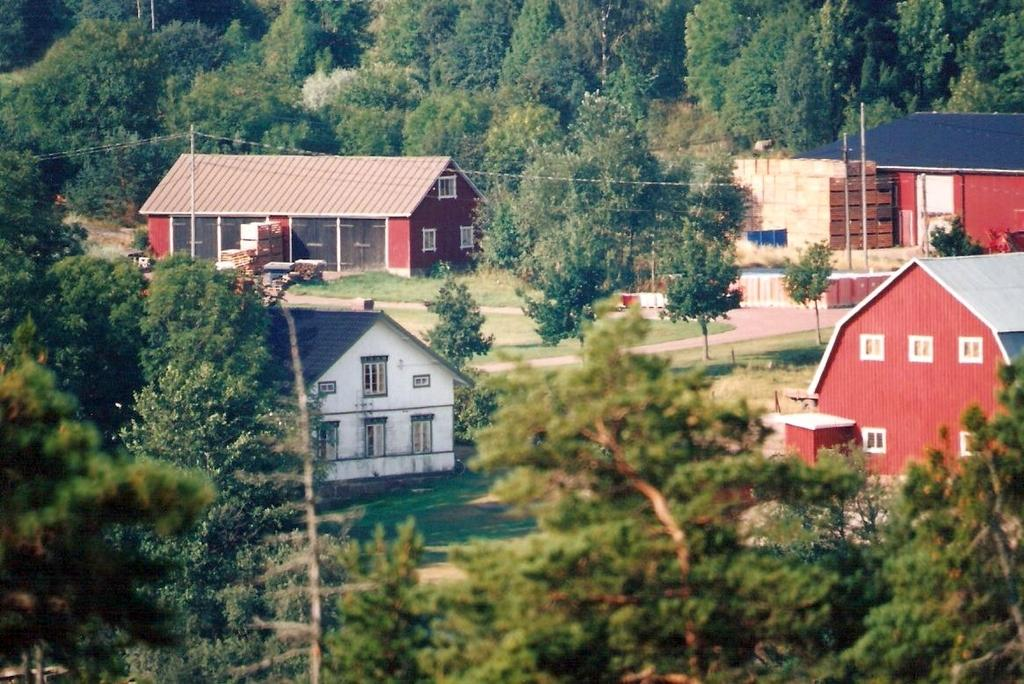What type of structures can be seen on the ground in the image? There are houses present on the ground in the image. What is covering part of the ground? Some part of the ground is covered with grass. What type of vegetation is present in the image? Plants and trees are present in the image. What type of care is being provided to the trees in the image? There is no indication in the image that any care is being provided to the trees. 